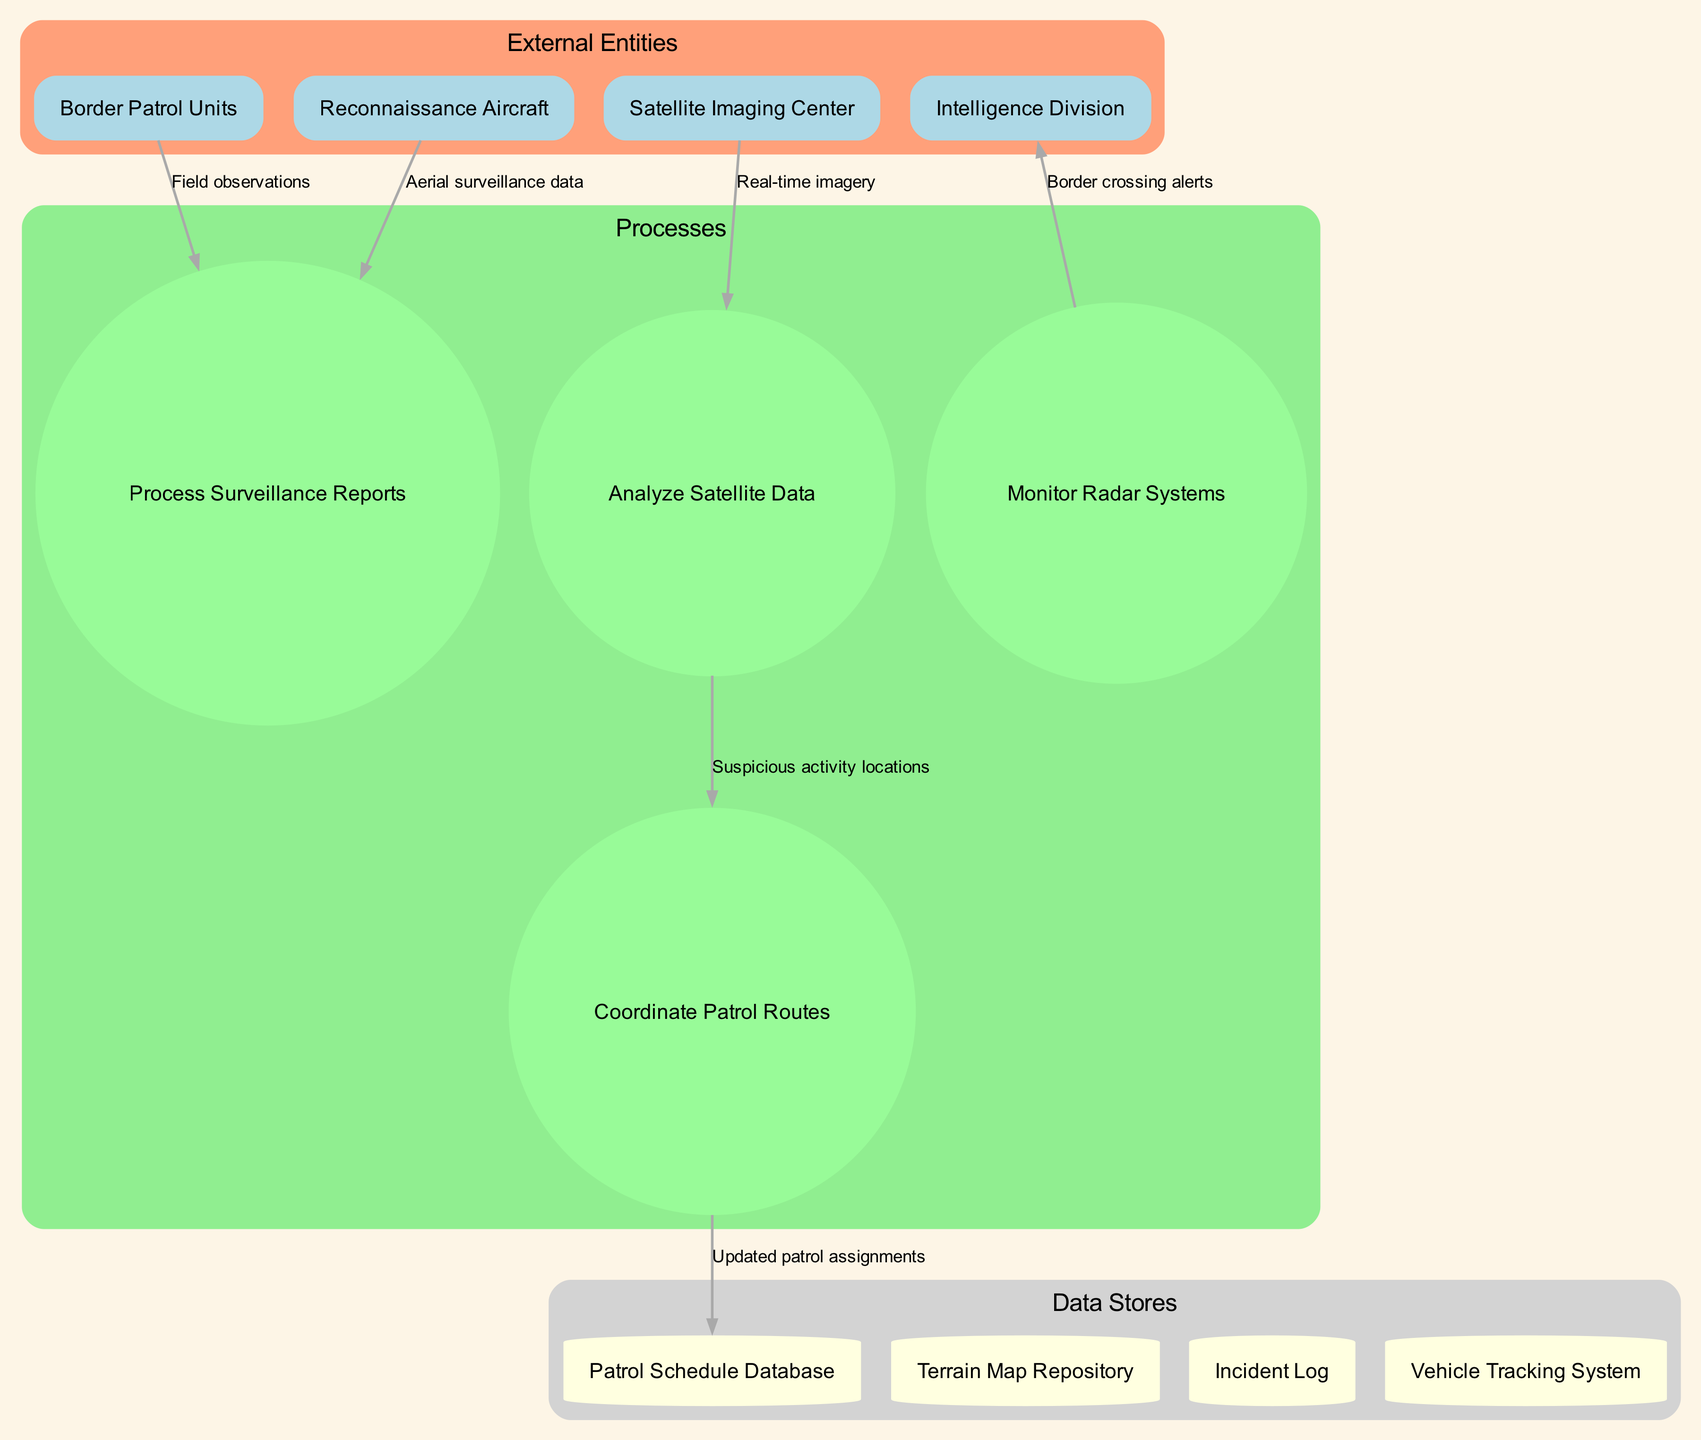What are the external entities in the diagram? The external entities listed in the diagram are provided as a distinct group. They include Border Patrol Units, Reconnaissance Aircraft, Satellite Imaging Center, and Intelligence Division.
Answer: Border Patrol Units, Reconnaissance Aircraft, Satellite Imaging Center, Intelligence Division How many processes are depicted in the diagram? The diagram specifies a total of four processes associated with the workflow. They include Analyze Satellite Data, Coordinate Patrol Routes, Process Surveillance Reports, and Monitor Radar Systems.
Answer: 4 Which process receives real-time imagery from the Satellite Imaging Center? The data flow shows that the real-time imagery is sent from the Satellite Imaging Center directly to the Analyze Satellite Data process.
Answer: Analyze Satellite Data What data flows from the Coordinate Patrol Routes process? The diagram indicates that updated patrol assignments flow from the Coordinate Patrol Routes process to the Patrol Schedule Database.
Answer: Updated patrol assignments From which external entity do field observations originate? The diagram identifies that field observations flow from the Border Patrol Units to the Process Surveillance Reports.
Answer: Border Patrol Units Which data store is associated with the monitoring of border crossing alerts? The Monitor Radar Systems process sends border crossing alerts to the Intelligence Division, but there is no data store associated directly with alerts in the diagram. Hence, the focus is on the process receiving the alerts.
Answer: Intelligence Division What is the data type being processed in surveillance reports? Two types of data are flowing into the Process Surveillance Reports process: field observations from Border Patrol Units and aerial surveillance data from Reconnaissance Aircraft. Therefore, the data types processed are these two distinct inputs.
Answer: Field observations, aerial surveillance data Which process updates the patrol assignments? The Coordinate Patrol Routes process is responsible for updating the patrol assignments, which are then sent to the Patrol Schedule Database.
Answer: Coordinate Patrol Routes How many data stores are present in the diagram? The diagram lists four data stores, which include Patrol Schedule Database, Terrain Map Repository, Incident Log, and Vehicle Tracking System.
Answer: 4 